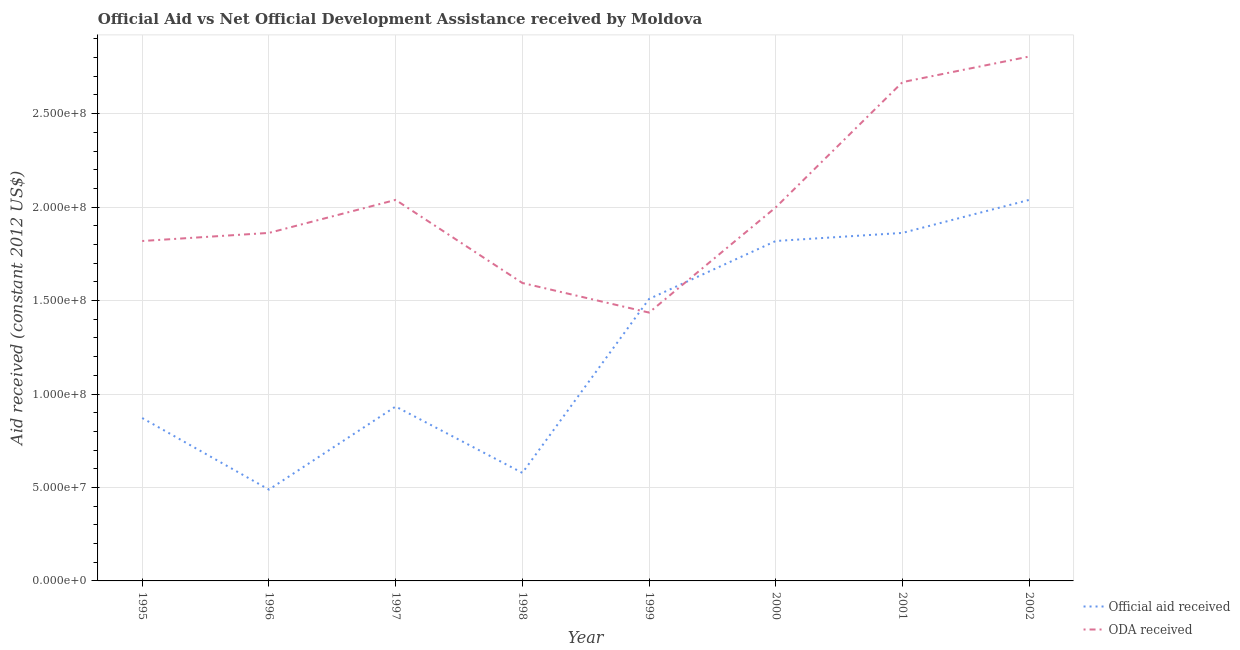Is the number of lines equal to the number of legend labels?
Keep it short and to the point. Yes. What is the oda received in 2002?
Give a very brief answer. 2.81e+08. Across all years, what is the maximum official aid received?
Provide a short and direct response. 2.04e+08. Across all years, what is the minimum official aid received?
Keep it short and to the point. 4.89e+07. In which year was the official aid received maximum?
Your answer should be compact. 2002. What is the total official aid received in the graph?
Your response must be concise. 1.01e+09. What is the difference between the oda received in 1995 and that in 1997?
Your response must be concise. -2.20e+07. What is the difference between the official aid received in 1997 and the oda received in 1995?
Keep it short and to the point. -8.86e+07. What is the average oda received per year?
Offer a terse response. 2.03e+08. In the year 1999, what is the difference between the oda received and official aid received?
Your response must be concise. -7.29e+06. What is the ratio of the official aid received in 1998 to that in 2000?
Offer a very short reply. 0.32. Is the difference between the oda received in 1999 and 2002 greater than the difference between the official aid received in 1999 and 2002?
Give a very brief answer. No. What is the difference between the highest and the second highest oda received?
Offer a terse response. 1.37e+07. What is the difference between the highest and the lowest oda received?
Provide a short and direct response. 1.37e+08. Does the oda received monotonically increase over the years?
Offer a very short reply. No. Is the oda received strictly less than the official aid received over the years?
Provide a succinct answer. No. How many lines are there?
Ensure brevity in your answer.  2. What is the difference between two consecutive major ticks on the Y-axis?
Keep it short and to the point. 5.00e+07. Are the values on the major ticks of Y-axis written in scientific E-notation?
Keep it short and to the point. Yes. Does the graph contain any zero values?
Ensure brevity in your answer.  No. Does the graph contain grids?
Make the answer very short. Yes. What is the title of the graph?
Provide a short and direct response. Official Aid vs Net Official Development Assistance received by Moldova . Does "Urban Population" appear as one of the legend labels in the graph?
Offer a very short reply. No. What is the label or title of the X-axis?
Give a very brief answer. Year. What is the label or title of the Y-axis?
Offer a terse response. Aid received (constant 2012 US$). What is the Aid received (constant 2012 US$) of Official aid received in 1995?
Your answer should be very brief. 8.72e+07. What is the Aid received (constant 2012 US$) of ODA received in 1995?
Offer a terse response. 1.82e+08. What is the Aid received (constant 2012 US$) of Official aid received in 1996?
Offer a terse response. 4.89e+07. What is the Aid received (constant 2012 US$) of ODA received in 1996?
Make the answer very short. 1.86e+08. What is the Aid received (constant 2012 US$) in Official aid received in 1997?
Ensure brevity in your answer.  9.33e+07. What is the Aid received (constant 2012 US$) of ODA received in 1997?
Your answer should be compact. 2.04e+08. What is the Aid received (constant 2012 US$) in Official aid received in 1998?
Provide a short and direct response. 5.78e+07. What is the Aid received (constant 2012 US$) in ODA received in 1998?
Offer a terse response. 1.59e+08. What is the Aid received (constant 2012 US$) in Official aid received in 1999?
Your response must be concise. 1.51e+08. What is the Aid received (constant 2012 US$) of ODA received in 1999?
Ensure brevity in your answer.  1.44e+08. What is the Aid received (constant 2012 US$) of Official aid received in 2000?
Make the answer very short. 1.82e+08. What is the Aid received (constant 2012 US$) in ODA received in 2000?
Give a very brief answer. 2.00e+08. What is the Aid received (constant 2012 US$) of Official aid received in 2001?
Your answer should be compact. 1.86e+08. What is the Aid received (constant 2012 US$) in ODA received in 2001?
Offer a very short reply. 2.67e+08. What is the Aid received (constant 2012 US$) in Official aid received in 2002?
Offer a very short reply. 2.04e+08. What is the Aid received (constant 2012 US$) of ODA received in 2002?
Provide a short and direct response. 2.81e+08. Across all years, what is the maximum Aid received (constant 2012 US$) of Official aid received?
Your answer should be compact. 2.04e+08. Across all years, what is the maximum Aid received (constant 2012 US$) of ODA received?
Offer a terse response. 2.81e+08. Across all years, what is the minimum Aid received (constant 2012 US$) of Official aid received?
Provide a succinct answer. 4.89e+07. Across all years, what is the minimum Aid received (constant 2012 US$) in ODA received?
Keep it short and to the point. 1.44e+08. What is the total Aid received (constant 2012 US$) in Official aid received in the graph?
Your response must be concise. 1.01e+09. What is the total Aid received (constant 2012 US$) of ODA received in the graph?
Offer a terse response. 1.62e+09. What is the difference between the Aid received (constant 2012 US$) in Official aid received in 1995 and that in 1996?
Give a very brief answer. 3.83e+07. What is the difference between the Aid received (constant 2012 US$) of ODA received in 1995 and that in 1996?
Ensure brevity in your answer.  -4.33e+06. What is the difference between the Aid received (constant 2012 US$) of Official aid received in 1995 and that in 1997?
Keep it short and to the point. -6.15e+06. What is the difference between the Aid received (constant 2012 US$) in ODA received in 1995 and that in 1997?
Your answer should be very brief. -2.20e+07. What is the difference between the Aid received (constant 2012 US$) of Official aid received in 1995 and that in 1998?
Provide a succinct answer. 2.93e+07. What is the difference between the Aid received (constant 2012 US$) of ODA received in 1995 and that in 1998?
Keep it short and to the point. 2.25e+07. What is the difference between the Aid received (constant 2012 US$) of Official aid received in 1995 and that in 1999?
Give a very brief answer. -6.37e+07. What is the difference between the Aid received (constant 2012 US$) of ODA received in 1995 and that in 1999?
Offer a terse response. 3.83e+07. What is the difference between the Aid received (constant 2012 US$) of Official aid received in 1995 and that in 2000?
Offer a very short reply. -9.47e+07. What is the difference between the Aid received (constant 2012 US$) in ODA received in 1995 and that in 2000?
Ensure brevity in your answer.  -1.80e+07. What is the difference between the Aid received (constant 2012 US$) in Official aid received in 1995 and that in 2001?
Give a very brief answer. -9.90e+07. What is the difference between the Aid received (constant 2012 US$) of ODA received in 1995 and that in 2001?
Keep it short and to the point. -8.50e+07. What is the difference between the Aid received (constant 2012 US$) in Official aid received in 1995 and that in 2002?
Your answer should be very brief. -1.17e+08. What is the difference between the Aid received (constant 2012 US$) in ODA received in 1995 and that in 2002?
Give a very brief answer. -9.87e+07. What is the difference between the Aid received (constant 2012 US$) of Official aid received in 1996 and that in 1997?
Provide a short and direct response. -4.44e+07. What is the difference between the Aid received (constant 2012 US$) in ODA received in 1996 and that in 1997?
Give a very brief answer. -1.77e+07. What is the difference between the Aid received (constant 2012 US$) in Official aid received in 1996 and that in 1998?
Keep it short and to the point. -8.95e+06. What is the difference between the Aid received (constant 2012 US$) of ODA received in 1996 and that in 1998?
Give a very brief answer. 2.68e+07. What is the difference between the Aid received (constant 2012 US$) of Official aid received in 1996 and that in 1999?
Provide a short and direct response. -1.02e+08. What is the difference between the Aid received (constant 2012 US$) of ODA received in 1996 and that in 1999?
Provide a short and direct response. 4.26e+07. What is the difference between the Aid received (constant 2012 US$) of Official aid received in 1996 and that in 2000?
Ensure brevity in your answer.  -1.33e+08. What is the difference between the Aid received (constant 2012 US$) of ODA received in 1996 and that in 2000?
Your answer should be compact. -1.37e+07. What is the difference between the Aid received (constant 2012 US$) in Official aid received in 1996 and that in 2001?
Your answer should be very brief. -1.37e+08. What is the difference between the Aid received (constant 2012 US$) in ODA received in 1996 and that in 2001?
Give a very brief answer. -8.07e+07. What is the difference between the Aid received (constant 2012 US$) of Official aid received in 1996 and that in 2002?
Keep it short and to the point. -1.55e+08. What is the difference between the Aid received (constant 2012 US$) of ODA received in 1996 and that in 2002?
Make the answer very short. -9.44e+07. What is the difference between the Aid received (constant 2012 US$) in Official aid received in 1997 and that in 1998?
Your answer should be very brief. 3.55e+07. What is the difference between the Aid received (constant 2012 US$) of ODA received in 1997 and that in 1998?
Keep it short and to the point. 4.44e+07. What is the difference between the Aid received (constant 2012 US$) of Official aid received in 1997 and that in 1999?
Provide a short and direct response. -5.76e+07. What is the difference between the Aid received (constant 2012 US$) in ODA received in 1997 and that in 1999?
Ensure brevity in your answer.  6.03e+07. What is the difference between the Aid received (constant 2012 US$) of Official aid received in 1997 and that in 2000?
Your answer should be very brief. -8.86e+07. What is the difference between the Aid received (constant 2012 US$) in ODA received in 1997 and that in 2000?
Provide a short and direct response. 3.98e+06. What is the difference between the Aid received (constant 2012 US$) of Official aid received in 1997 and that in 2001?
Provide a short and direct response. -9.29e+07. What is the difference between the Aid received (constant 2012 US$) of ODA received in 1997 and that in 2001?
Provide a succinct answer. -6.30e+07. What is the difference between the Aid received (constant 2012 US$) of Official aid received in 1997 and that in 2002?
Provide a succinct answer. -1.11e+08. What is the difference between the Aid received (constant 2012 US$) of ODA received in 1997 and that in 2002?
Offer a very short reply. -7.67e+07. What is the difference between the Aid received (constant 2012 US$) in Official aid received in 1998 and that in 1999?
Make the answer very short. -9.30e+07. What is the difference between the Aid received (constant 2012 US$) in ODA received in 1998 and that in 1999?
Provide a succinct answer. 1.58e+07. What is the difference between the Aid received (constant 2012 US$) of Official aid received in 1998 and that in 2000?
Your answer should be very brief. -1.24e+08. What is the difference between the Aid received (constant 2012 US$) in ODA received in 1998 and that in 2000?
Give a very brief answer. -4.05e+07. What is the difference between the Aid received (constant 2012 US$) in Official aid received in 1998 and that in 2001?
Provide a short and direct response. -1.28e+08. What is the difference between the Aid received (constant 2012 US$) of ODA received in 1998 and that in 2001?
Your answer should be very brief. -1.07e+08. What is the difference between the Aid received (constant 2012 US$) of Official aid received in 1998 and that in 2002?
Provide a short and direct response. -1.46e+08. What is the difference between the Aid received (constant 2012 US$) of ODA received in 1998 and that in 2002?
Your response must be concise. -1.21e+08. What is the difference between the Aid received (constant 2012 US$) of Official aid received in 1999 and that in 2000?
Your response must be concise. -3.10e+07. What is the difference between the Aid received (constant 2012 US$) of ODA received in 1999 and that in 2000?
Make the answer very short. -5.63e+07. What is the difference between the Aid received (constant 2012 US$) of Official aid received in 1999 and that in 2001?
Offer a terse response. -3.53e+07. What is the difference between the Aid received (constant 2012 US$) in ODA received in 1999 and that in 2001?
Give a very brief answer. -1.23e+08. What is the difference between the Aid received (constant 2012 US$) of Official aid received in 1999 and that in 2002?
Your response must be concise. -5.30e+07. What is the difference between the Aid received (constant 2012 US$) of ODA received in 1999 and that in 2002?
Offer a very short reply. -1.37e+08. What is the difference between the Aid received (constant 2012 US$) of Official aid received in 2000 and that in 2001?
Provide a short and direct response. -4.33e+06. What is the difference between the Aid received (constant 2012 US$) in ODA received in 2000 and that in 2001?
Make the answer very short. -6.70e+07. What is the difference between the Aid received (constant 2012 US$) in Official aid received in 2000 and that in 2002?
Offer a terse response. -2.20e+07. What is the difference between the Aid received (constant 2012 US$) in ODA received in 2000 and that in 2002?
Give a very brief answer. -8.07e+07. What is the difference between the Aid received (constant 2012 US$) in Official aid received in 2001 and that in 2002?
Provide a succinct answer. -1.77e+07. What is the difference between the Aid received (constant 2012 US$) of ODA received in 2001 and that in 2002?
Your answer should be very brief. -1.37e+07. What is the difference between the Aid received (constant 2012 US$) of Official aid received in 1995 and the Aid received (constant 2012 US$) of ODA received in 1996?
Ensure brevity in your answer.  -9.90e+07. What is the difference between the Aid received (constant 2012 US$) of Official aid received in 1995 and the Aid received (constant 2012 US$) of ODA received in 1997?
Provide a short and direct response. -1.17e+08. What is the difference between the Aid received (constant 2012 US$) of Official aid received in 1995 and the Aid received (constant 2012 US$) of ODA received in 1998?
Offer a terse response. -7.22e+07. What is the difference between the Aid received (constant 2012 US$) in Official aid received in 1995 and the Aid received (constant 2012 US$) in ODA received in 1999?
Your answer should be very brief. -5.64e+07. What is the difference between the Aid received (constant 2012 US$) in Official aid received in 1995 and the Aid received (constant 2012 US$) in ODA received in 2000?
Make the answer very short. -1.13e+08. What is the difference between the Aid received (constant 2012 US$) in Official aid received in 1995 and the Aid received (constant 2012 US$) in ODA received in 2001?
Your answer should be compact. -1.80e+08. What is the difference between the Aid received (constant 2012 US$) in Official aid received in 1995 and the Aid received (constant 2012 US$) in ODA received in 2002?
Offer a very short reply. -1.93e+08. What is the difference between the Aid received (constant 2012 US$) in Official aid received in 1996 and the Aid received (constant 2012 US$) in ODA received in 1997?
Give a very brief answer. -1.55e+08. What is the difference between the Aid received (constant 2012 US$) in Official aid received in 1996 and the Aid received (constant 2012 US$) in ODA received in 1998?
Provide a short and direct response. -1.11e+08. What is the difference between the Aid received (constant 2012 US$) of Official aid received in 1996 and the Aid received (constant 2012 US$) of ODA received in 1999?
Provide a short and direct response. -9.47e+07. What is the difference between the Aid received (constant 2012 US$) in Official aid received in 1996 and the Aid received (constant 2012 US$) in ODA received in 2000?
Make the answer very short. -1.51e+08. What is the difference between the Aid received (constant 2012 US$) in Official aid received in 1996 and the Aid received (constant 2012 US$) in ODA received in 2001?
Your answer should be compact. -2.18e+08. What is the difference between the Aid received (constant 2012 US$) in Official aid received in 1996 and the Aid received (constant 2012 US$) in ODA received in 2002?
Your answer should be compact. -2.32e+08. What is the difference between the Aid received (constant 2012 US$) of Official aid received in 1997 and the Aid received (constant 2012 US$) of ODA received in 1998?
Your answer should be compact. -6.61e+07. What is the difference between the Aid received (constant 2012 US$) in Official aid received in 1997 and the Aid received (constant 2012 US$) in ODA received in 1999?
Your answer should be compact. -5.03e+07. What is the difference between the Aid received (constant 2012 US$) of Official aid received in 1997 and the Aid received (constant 2012 US$) of ODA received in 2000?
Offer a terse response. -1.07e+08. What is the difference between the Aid received (constant 2012 US$) in Official aid received in 1997 and the Aid received (constant 2012 US$) in ODA received in 2001?
Keep it short and to the point. -1.74e+08. What is the difference between the Aid received (constant 2012 US$) in Official aid received in 1997 and the Aid received (constant 2012 US$) in ODA received in 2002?
Ensure brevity in your answer.  -1.87e+08. What is the difference between the Aid received (constant 2012 US$) of Official aid received in 1998 and the Aid received (constant 2012 US$) of ODA received in 1999?
Provide a succinct answer. -8.58e+07. What is the difference between the Aid received (constant 2012 US$) of Official aid received in 1998 and the Aid received (constant 2012 US$) of ODA received in 2000?
Keep it short and to the point. -1.42e+08. What is the difference between the Aid received (constant 2012 US$) of Official aid received in 1998 and the Aid received (constant 2012 US$) of ODA received in 2001?
Offer a very short reply. -2.09e+08. What is the difference between the Aid received (constant 2012 US$) in Official aid received in 1998 and the Aid received (constant 2012 US$) in ODA received in 2002?
Ensure brevity in your answer.  -2.23e+08. What is the difference between the Aid received (constant 2012 US$) in Official aid received in 1999 and the Aid received (constant 2012 US$) in ODA received in 2000?
Offer a terse response. -4.90e+07. What is the difference between the Aid received (constant 2012 US$) in Official aid received in 1999 and the Aid received (constant 2012 US$) in ODA received in 2001?
Offer a terse response. -1.16e+08. What is the difference between the Aid received (constant 2012 US$) of Official aid received in 1999 and the Aid received (constant 2012 US$) of ODA received in 2002?
Provide a short and direct response. -1.30e+08. What is the difference between the Aid received (constant 2012 US$) of Official aid received in 2000 and the Aid received (constant 2012 US$) of ODA received in 2001?
Give a very brief answer. -8.50e+07. What is the difference between the Aid received (constant 2012 US$) in Official aid received in 2000 and the Aid received (constant 2012 US$) in ODA received in 2002?
Give a very brief answer. -9.87e+07. What is the difference between the Aid received (constant 2012 US$) of Official aid received in 2001 and the Aid received (constant 2012 US$) of ODA received in 2002?
Offer a very short reply. -9.44e+07. What is the average Aid received (constant 2012 US$) in Official aid received per year?
Provide a short and direct response. 1.26e+08. What is the average Aid received (constant 2012 US$) in ODA received per year?
Ensure brevity in your answer.  2.03e+08. In the year 1995, what is the difference between the Aid received (constant 2012 US$) of Official aid received and Aid received (constant 2012 US$) of ODA received?
Make the answer very short. -9.47e+07. In the year 1996, what is the difference between the Aid received (constant 2012 US$) in Official aid received and Aid received (constant 2012 US$) in ODA received?
Offer a terse response. -1.37e+08. In the year 1997, what is the difference between the Aid received (constant 2012 US$) in Official aid received and Aid received (constant 2012 US$) in ODA received?
Your answer should be very brief. -1.11e+08. In the year 1998, what is the difference between the Aid received (constant 2012 US$) in Official aid received and Aid received (constant 2012 US$) in ODA received?
Ensure brevity in your answer.  -1.02e+08. In the year 1999, what is the difference between the Aid received (constant 2012 US$) of Official aid received and Aid received (constant 2012 US$) of ODA received?
Keep it short and to the point. 7.29e+06. In the year 2000, what is the difference between the Aid received (constant 2012 US$) in Official aid received and Aid received (constant 2012 US$) in ODA received?
Make the answer very short. -1.80e+07. In the year 2001, what is the difference between the Aid received (constant 2012 US$) in Official aid received and Aid received (constant 2012 US$) in ODA received?
Your response must be concise. -8.07e+07. In the year 2002, what is the difference between the Aid received (constant 2012 US$) in Official aid received and Aid received (constant 2012 US$) in ODA received?
Ensure brevity in your answer.  -7.67e+07. What is the ratio of the Aid received (constant 2012 US$) in Official aid received in 1995 to that in 1996?
Your answer should be very brief. 1.78. What is the ratio of the Aid received (constant 2012 US$) of ODA received in 1995 to that in 1996?
Ensure brevity in your answer.  0.98. What is the ratio of the Aid received (constant 2012 US$) of Official aid received in 1995 to that in 1997?
Your answer should be compact. 0.93. What is the ratio of the Aid received (constant 2012 US$) of ODA received in 1995 to that in 1997?
Your answer should be very brief. 0.89. What is the ratio of the Aid received (constant 2012 US$) in Official aid received in 1995 to that in 1998?
Provide a succinct answer. 1.51. What is the ratio of the Aid received (constant 2012 US$) of ODA received in 1995 to that in 1998?
Make the answer very short. 1.14. What is the ratio of the Aid received (constant 2012 US$) in Official aid received in 1995 to that in 1999?
Ensure brevity in your answer.  0.58. What is the ratio of the Aid received (constant 2012 US$) of ODA received in 1995 to that in 1999?
Make the answer very short. 1.27. What is the ratio of the Aid received (constant 2012 US$) of Official aid received in 1995 to that in 2000?
Provide a succinct answer. 0.48. What is the ratio of the Aid received (constant 2012 US$) of ODA received in 1995 to that in 2000?
Your answer should be compact. 0.91. What is the ratio of the Aid received (constant 2012 US$) in Official aid received in 1995 to that in 2001?
Provide a succinct answer. 0.47. What is the ratio of the Aid received (constant 2012 US$) of ODA received in 1995 to that in 2001?
Your answer should be compact. 0.68. What is the ratio of the Aid received (constant 2012 US$) of Official aid received in 1995 to that in 2002?
Ensure brevity in your answer.  0.43. What is the ratio of the Aid received (constant 2012 US$) in ODA received in 1995 to that in 2002?
Keep it short and to the point. 0.65. What is the ratio of the Aid received (constant 2012 US$) in Official aid received in 1996 to that in 1997?
Give a very brief answer. 0.52. What is the ratio of the Aid received (constant 2012 US$) in ODA received in 1996 to that in 1997?
Provide a short and direct response. 0.91. What is the ratio of the Aid received (constant 2012 US$) of Official aid received in 1996 to that in 1998?
Give a very brief answer. 0.85. What is the ratio of the Aid received (constant 2012 US$) in ODA received in 1996 to that in 1998?
Offer a very short reply. 1.17. What is the ratio of the Aid received (constant 2012 US$) of Official aid received in 1996 to that in 1999?
Keep it short and to the point. 0.32. What is the ratio of the Aid received (constant 2012 US$) in ODA received in 1996 to that in 1999?
Offer a very short reply. 1.3. What is the ratio of the Aid received (constant 2012 US$) of Official aid received in 1996 to that in 2000?
Offer a very short reply. 0.27. What is the ratio of the Aid received (constant 2012 US$) in ODA received in 1996 to that in 2000?
Ensure brevity in your answer.  0.93. What is the ratio of the Aid received (constant 2012 US$) of Official aid received in 1996 to that in 2001?
Keep it short and to the point. 0.26. What is the ratio of the Aid received (constant 2012 US$) in ODA received in 1996 to that in 2001?
Ensure brevity in your answer.  0.7. What is the ratio of the Aid received (constant 2012 US$) in Official aid received in 1996 to that in 2002?
Offer a very short reply. 0.24. What is the ratio of the Aid received (constant 2012 US$) in ODA received in 1996 to that in 2002?
Give a very brief answer. 0.66. What is the ratio of the Aid received (constant 2012 US$) of Official aid received in 1997 to that in 1998?
Give a very brief answer. 1.61. What is the ratio of the Aid received (constant 2012 US$) in ODA received in 1997 to that in 1998?
Give a very brief answer. 1.28. What is the ratio of the Aid received (constant 2012 US$) of Official aid received in 1997 to that in 1999?
Your answer should be compact. 0.62. What is the ratio of the Aid received (constant 2012 US$) of ODA received in 1997 to that in 1999?
Provide a succinct answer. 1.42. What is the ratio of the Aid received (constant 2012 US$) of Official aid received in 1997 to that in 2000?
Provide a succinct answer. 0.51. What is the ratio of the Aid received (constant 2012 US$) of ODA received in 1997 to that in 2000?
Your answer should be very brief. 1.02. What is the ratio of the Aid received (constant 2012 US$) of Official aid received in 1997 to that in 2001?
Keep it short and to the point. 0.5. What is the ratio of the Aid received (constant 2012 US$) of ODA received in 1997 to that in 2001?
Your answer should be compact. 0.76. What is the ratio of the Aid received (constant 2012 US$) of Official aid received in 1997 to that in 2002?
Offer a very short reply. 0.46. What is the ratio of the Aid received (constant 2012 US$) of ODA received in 1997 to that in 2002?
Your response must be concise. 0.73. What is the ratio of the Aid received (constant 2012 US$) in Official aid received in 1998 to that in 1999?
Provide a succinct answer. 0.38. What is the ratio of the Aid received (constant 2012 US$) of ODA received in 1998 to that in 1999?
Provide a succinct answer. 1.11. What is the ratio of the Aid received (constant 2012 US$) of Official aid received in 1998 to that in 2000?
Your response must be concise. 0.32. What is the ratio of the Aid received (constant 2012 US$) in ODA received in 1998 to that in 2000?
Provide a short and direct response. 0.8. What is the ratio of the Aid received (constant 2012 US$) of Official aid received in 1998 to that in 2001?
Offer a terse response. 0.31. What is the ratio of the Aid received (constant 2012 US$) in ODA received in 1998 to that in 2001?
Your answer should be compact. 0.6. What is the ratio of the Aid received (constant 2012 US$) of Official aid received in 1998 to that in 2002?
Provide a short and direct response. 0.28. What is the ratio of the Aid received (constant 2012 US$) of ODA received in 1998 to that in 2002?
Offer a very short reply. 0.57. What is the ratio of the Aid received (constant 2012 US$) in Official aid received in 1999 to that in 2000?
Keep it short and to the point. 0.83. What is the ratio of the Aid received (constant 2012 US$) in ODA received in 1999 to that in 2000?
Provide a succinct answer. 0.72. What is the ratio of the Aid received (constant 2012 US$) in Official aid received in 1999 to that in 2001?
Your answer should be very brief. 0.81. What is the ratio of the Aid received (constant 2012 US$) in ODA received in 1999 to that in 2001?
Keep it short and to the point. 0.54. What is the ratio of the Aid received (constant 2012 US$) in Official aid received in 1999 to that in 2002?
Give a very brief answer. 0.74. What is the ratio of the Aid received (constant 2012 US$) of ODA received in 1999 to that in 2002?
Your answer should be compact. 0.51. What is the ratio of the Aid received (constant 2012 US$) of Official aid received in 2000 to that in 2001?
Offer a terse response. 0.98. What is the ratio of the Aid received (constant 2012 US$) in ODA received in 2000 to that in 2001?
Keep it short and to the point. 0.75. What is the ratio of the Aid received (constant 2012 US$) of Official aid received in 2000 to that in 2002?
Keep it short and to the point. 0.89. What is the ratio of the Aid received (constant 2012 US$) of ODA received in 2000 to that in 2002?
Give a very brief answer. 0.71. What is the ratio of the Aid received (constant 2012 US$) of Official aid received in 2001 to that in 2002?
Your answer should be very brief. 0.91. What is the ratio of the Aid received (constant 2012 US$) in ODA received in 2001 to that in 2002?
Provide a short and direct response. 0.95. What is the difference between the highest and the second highest Aid received (constant 2012 US$) in Official aid received?
Offer a terse response. 1.77e+07. What is the difference between the highest and the second highest Aid received (constant 2012 US$) of ODA received?
Keep it short and to the point. 1.37e+07. What is the difference between the highest and the lowest Aid received (constant 2012 US$) of Official aid received?
Your response must be concise. 1.55e+08. What is the difference between the highest and the lowest Aid received (constant 2012 US$) in ODA received?
Your response must be concise. 1.37e+08. 